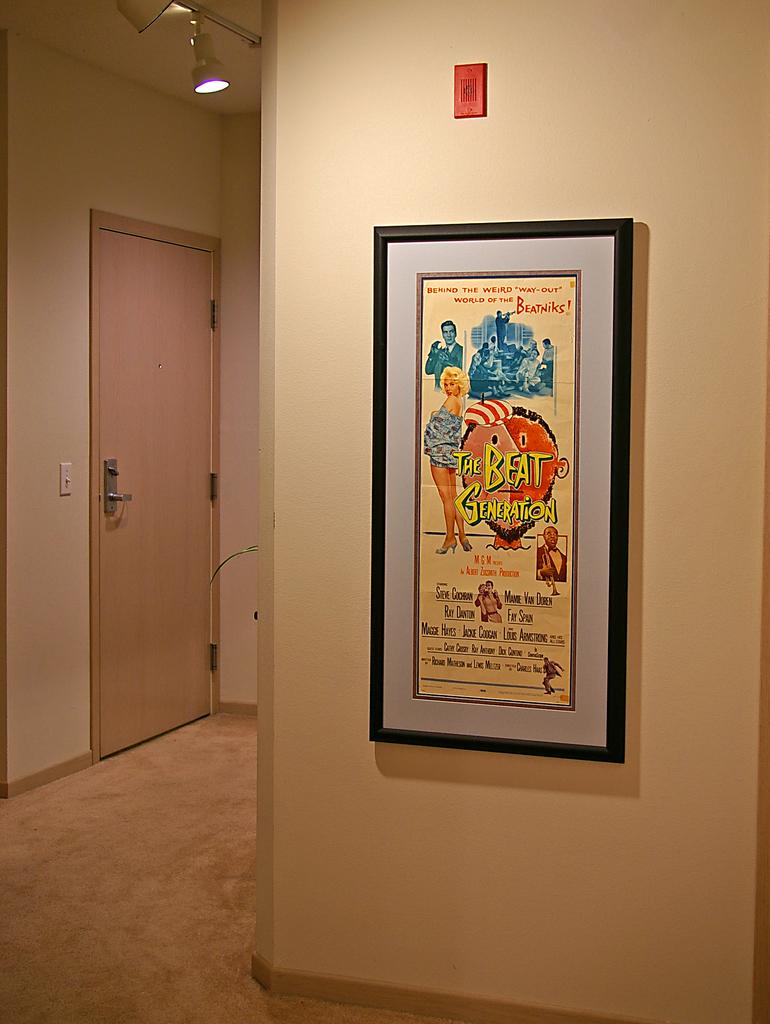What is the name of the movie on the poster?
Give a very brief answer. The beat generation. 